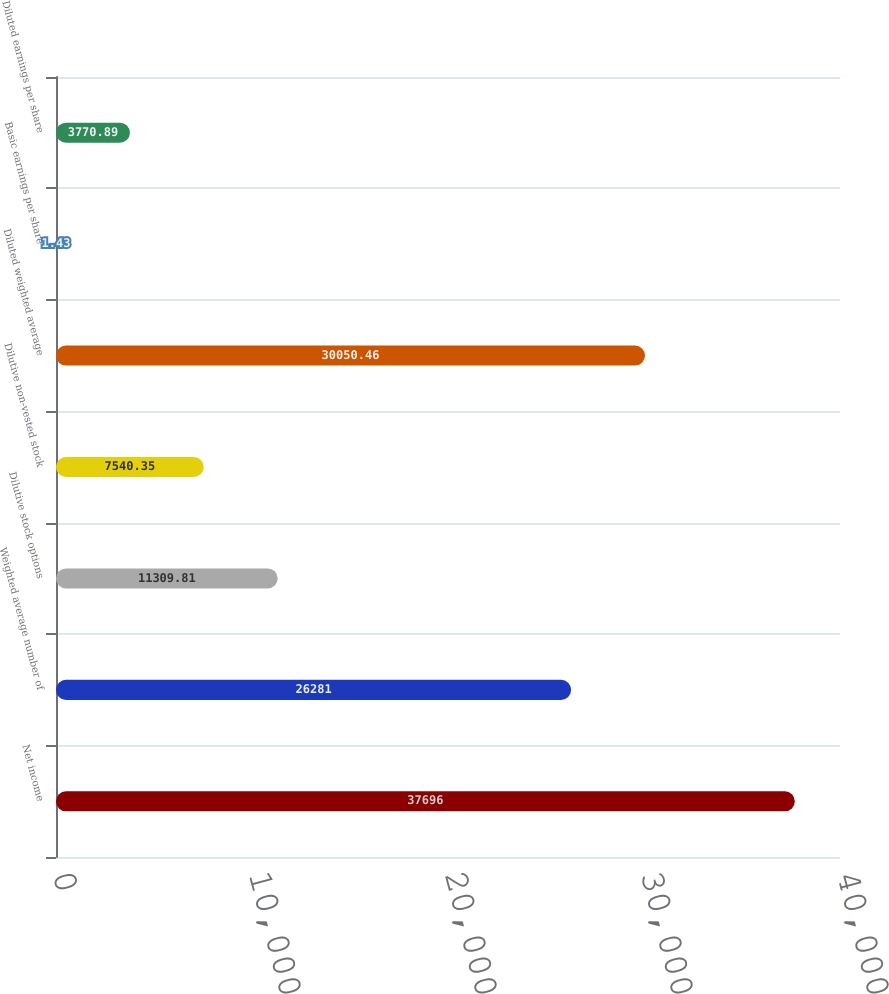Convert chart to OTSL. <chart><loc_0><loc_0><loc_500><loc_500><bar_chart><fcel>Net income<fcel>Weighted average number of<fcel>Dilutive stock options<fcel>Dilutive non-vested stock<fcel>Diluted weighted average<fcel>Basic earnings per share<fcel>Diluted earnings per share<nl><fcel>37696<fcel>26281<fcel>11309.8<fcel>7540.35<fcel>30050.5<fcel>1.43<fcel>3770.89<nl></chart> 